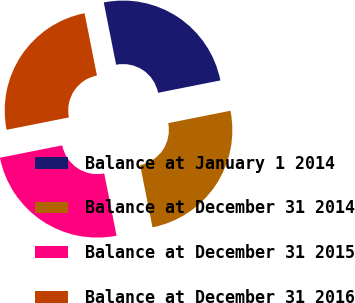Convert chart to OTSL. <chart><loc_0><loc_0><loc_500><loc_500><pie_chart><fcel>Balance at January 1 2014<fcel>Balance at December 31 2014<fcel>Balance at December 31 2015<fcel>Balance at December 31 2016<nl><fcel>25.0%<fcel>25.0%<fcel>25.0%<fcel>25.0%<nl></chart> 